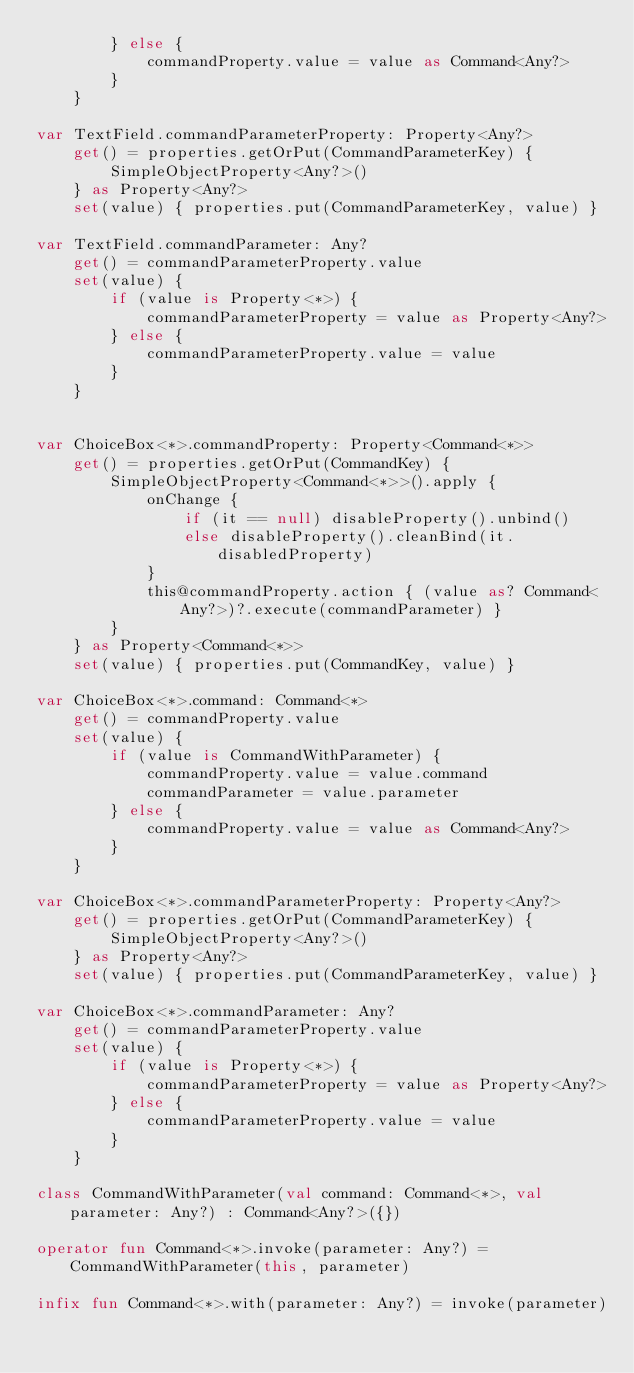<code> <loc_0><loc_0><loc_500><loc_500><_Kotlin_>        } else {
            commandProperty.value = value as Command<Any?>
        }
    }

var TextField.commandParameterProperty: Property<Any?>
    get() = properties.getOrPut(CommandParameterKey) {
        SimpleObjectProperty<Any?>()
    } as Property<Any?>
    set(value) { properties.put(CommandParameterKey, value) }

var TextField.commandParameter: Any?
    get() = commandParameterProperty.value
    set(value) {
        if (value is Property<*>) {
            commandParameterProperty = value as Property<Any?>
        } else {
            commandParameterProperty.value = value
        }
    }


var ChoiceBox<*>.commandProperty: Property<Command<*>>
    get() = properties.getOrPut(CommandKey) {
        SimpleObjectProperty<Command<*>>().apply {
            onChange {
                if (it == null) disableProperty().unbind()
                else disableProperty().cleanBind(it.disabledProperty)
            }
            this@commandProperty.action { (value as? Command<Any?>)?.execute(commandParameter) }
        }
    } as Property<Command<*>>
    set(value) { properties.put(CommandKey, value) }

var ChoiceBox<*>.command: Command<*>
    get() = commandProperty.value
    set(value) {
        if (value is CommandWithParameter) {
            commandProperty.value = value.command
            commandParameter = value.parameter
        } else {
            commandProperty.value = value as Command<Any?>
        }
    }

var ChoiceBox<*>.commandParameterProperty: Property<Any?>
    get() = properties.getOrPut(CommandParameterKey) {
        SimpleObjectProperty<Any?>()
    } as Property<Any?>
    set(value) { properties.put(CommandParameterKey, value) }

var ChoiceBox<*>.commandParameter: Any?
    get() = commandParameterProperty.value
    set(value) {
        if (value is Property<*>) {
            commandParameterProperty = value as Property<Any?>
        } else {
            commandParameterProperty.value = value
        }
    }

class CommandWithParameter(val command: Command<*>, val parameter: Any?) : Command<Any?>({})

operator fun Command<*>.invoke(parameter: Any?) = CommandWithParameter(this, parameter)

infix fun Command<*>.with(parameter: Any?) = invoke(parameter)
</code> 